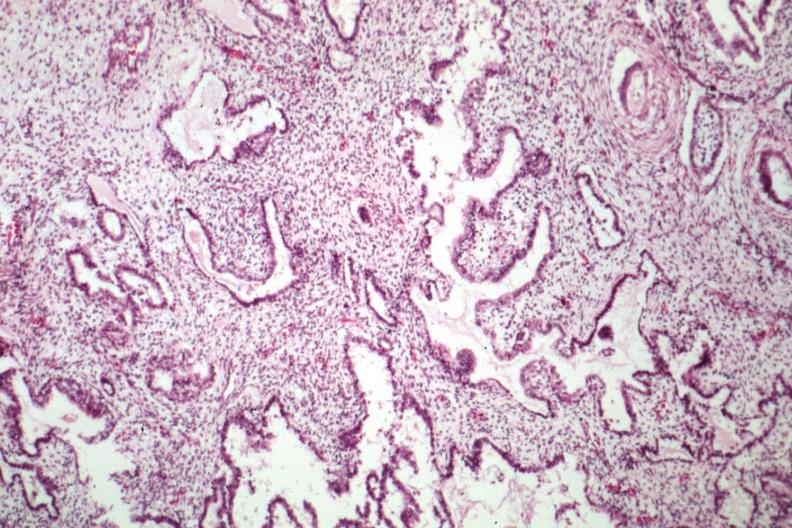what does this image show?
Answer the question using a single word or phrase. Epithelial component resembling endometrium 